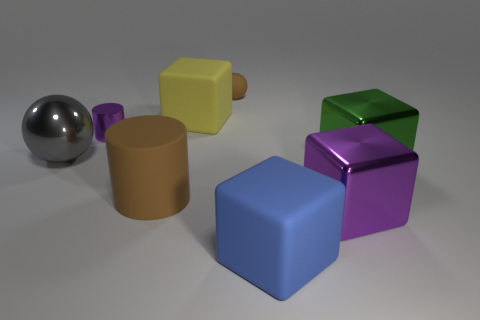Subtract all big purple metallic blocks. How many blocks are left? 3 Add 1 tiny yellow objects. How many objects exist? 9 Subtract all purple blocks. How many blocks are left? 3 Subtract all spheres. How many objects are left? 6 Add 6 small brown objects. How many small brown objects are left? 7 Add 8 green blocks. How many green blocks exist? 9 Subtract 0 red balls. How many objects are left? 8 Subtract all cyan cylinders. Subtract all brown cubes. How many cylinders are left? 2 Subtract all blue matte cubes. Subtract all big yellow things. How many objects are left? 6 